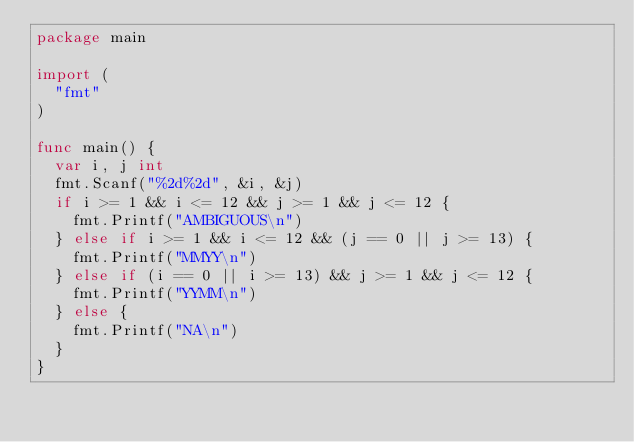<code> <loc_0><loc_0><loc_500><loc_500><_Go_>package main

import (
	"fmt"
)

func main() {
	var i, j int
	fmt.Scanf("%2d%2d", &i, &j)
	if i >= 1 && i <= 12 && j >= 1 && j <= 12 {
		fmt.Printf("AMBIGUOUS\n")
	} else if i >= 1 && i <= 12 && (j == 0 || j >= 13) {
		fmt.Printf("MMYY\n")
	} else if (i == 0 || i >= 13) && j >= 1 && j <= 12 {
		fmt.Printf("YYMM\n")
	} else {
		fmt.Printf("NA\n")
	}
}
</code> 